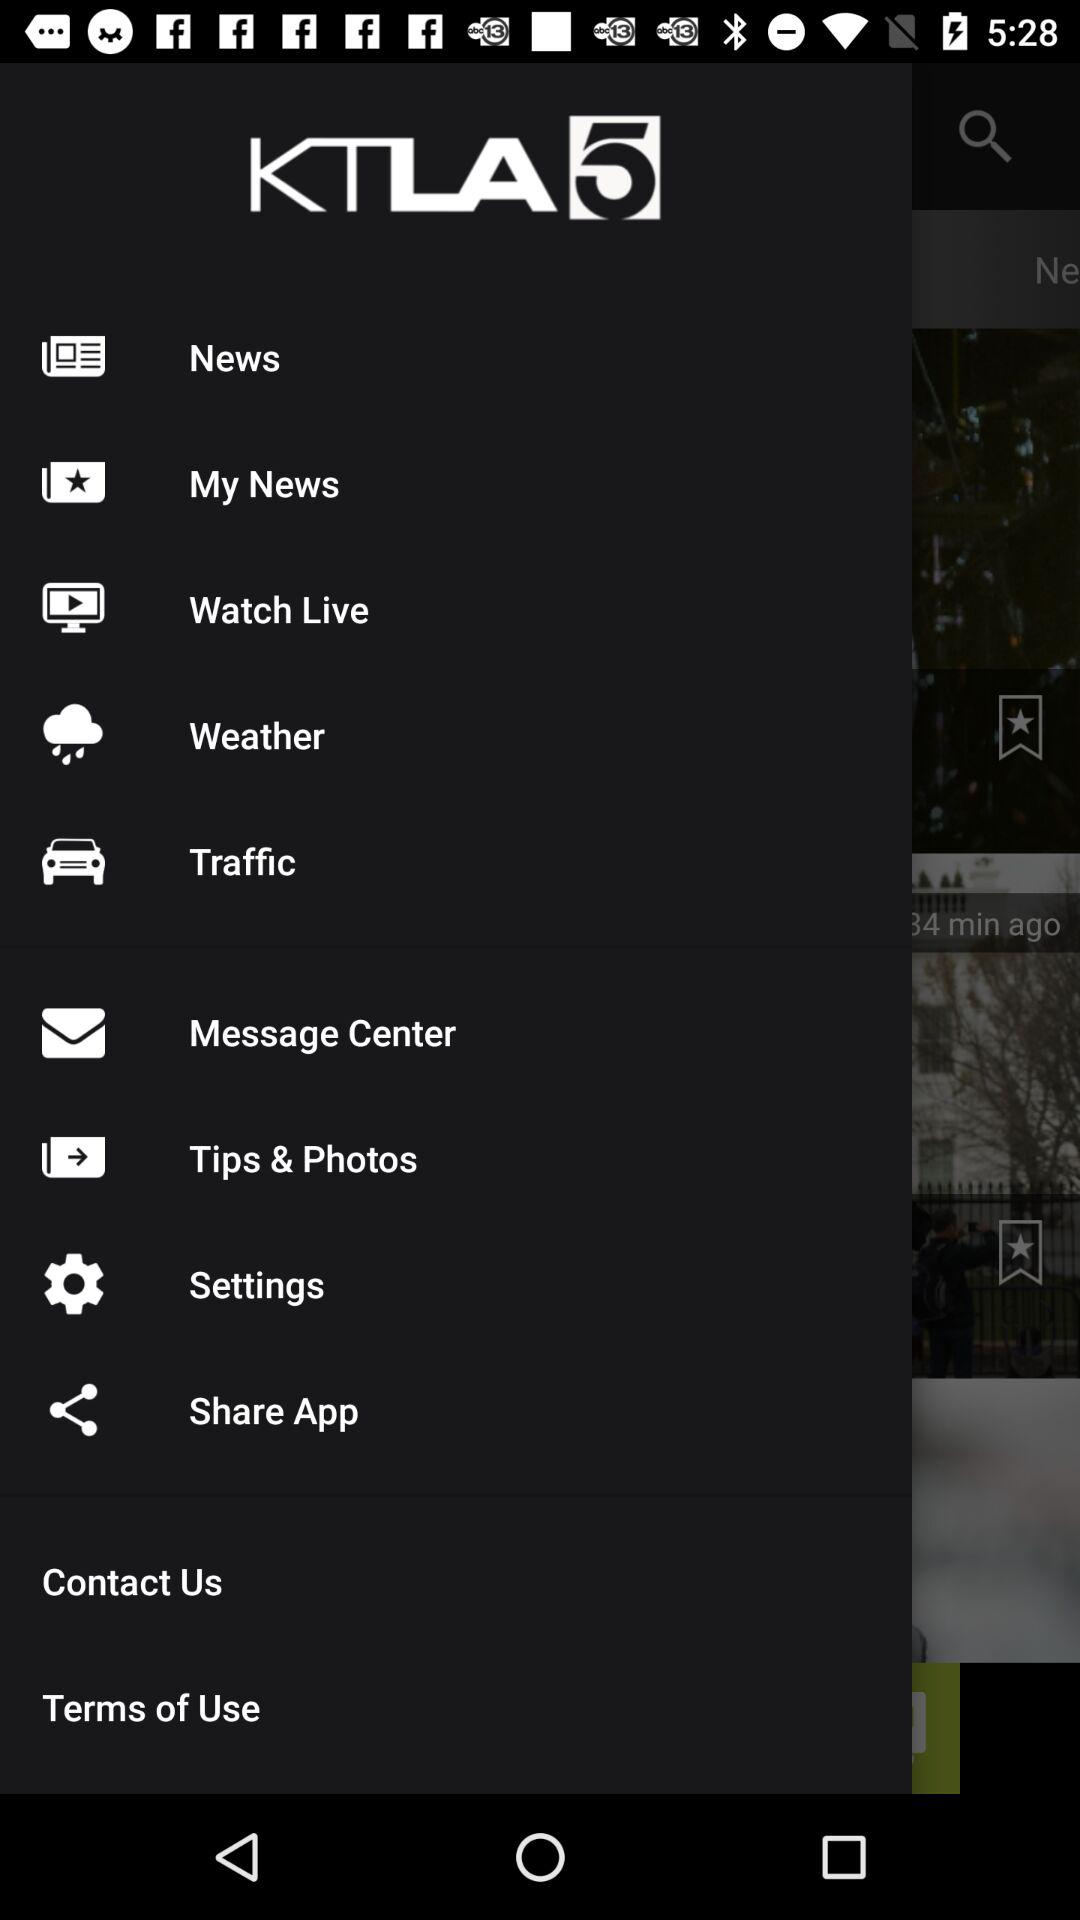What is the application name? The application name is "KTLA 5". 